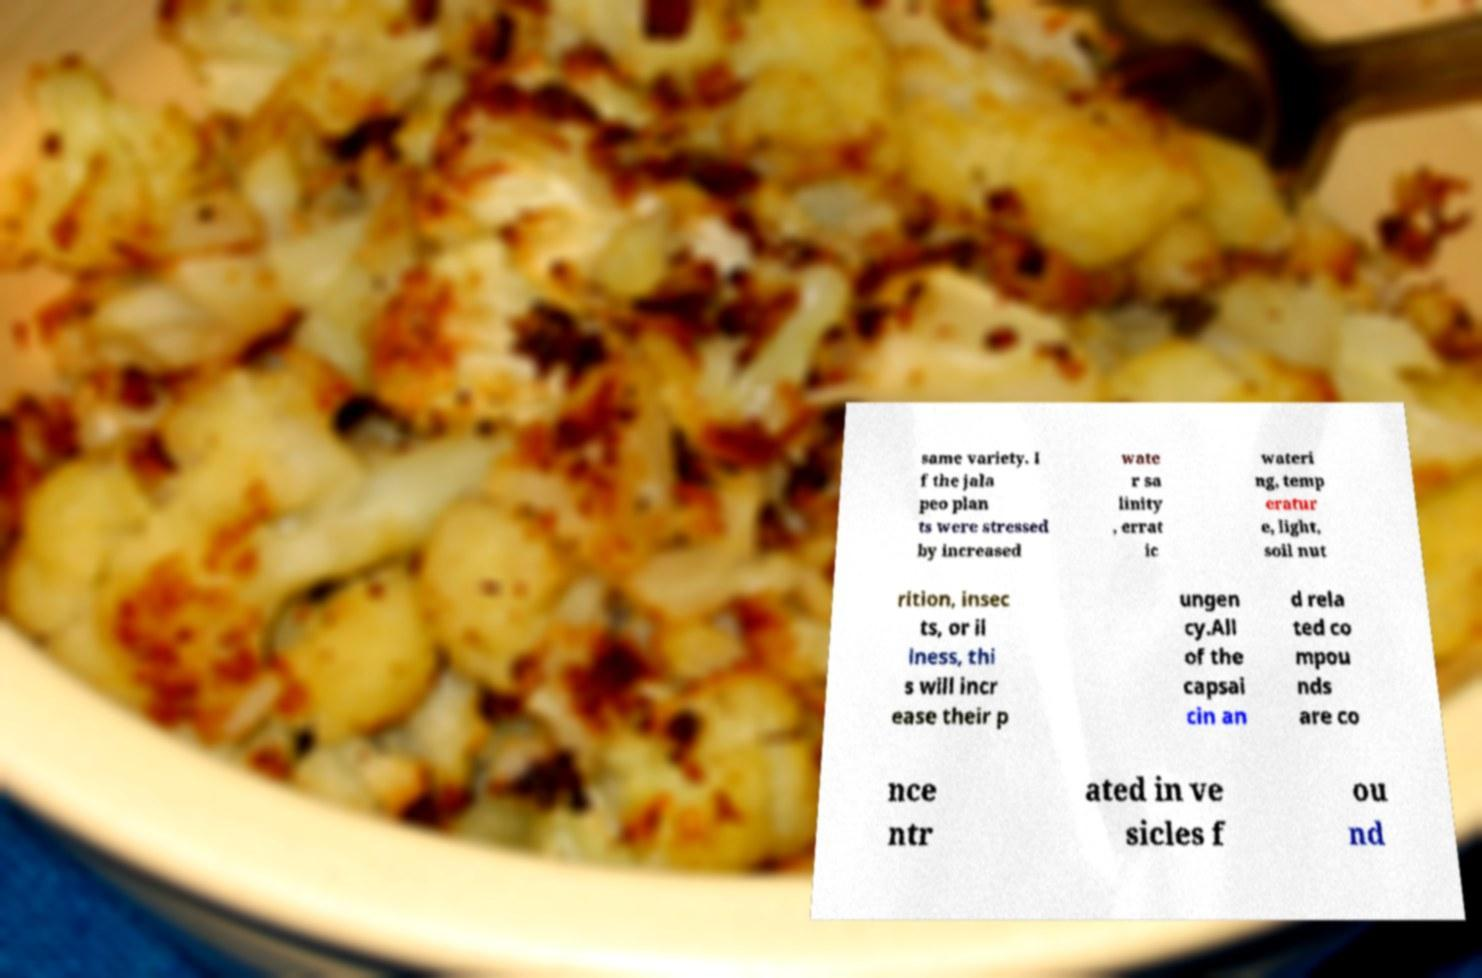Could you extract and type out the text from this image? same variety. I f the jala peo plan ts were stressed by increased wate r sa linity , errat ic wateri ng, temp eratur e, light, soil nut rition, insec ts, or il lness, thi s will incr ease their p ungen cy.All of the capsai cin an d rela ted co mpou nds are co nce ntr ated in ve sicles f ou nd 